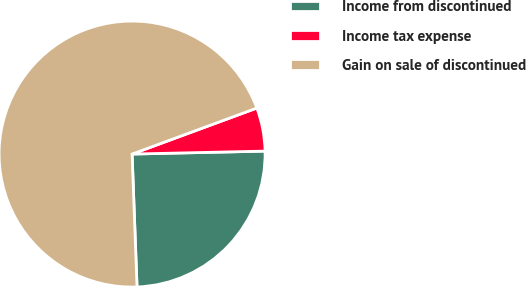Convert chart to OTSL. <chart><loc_0><loc_0><loc_500><loc_500><pie_chart><fcel>Income from discontinued<fcel>Income tax expense<fcel>Gain on sale of discontinued<nl><fcel>24.76%<fcel>5.27%<fcel>69.96%<nl></chart> 